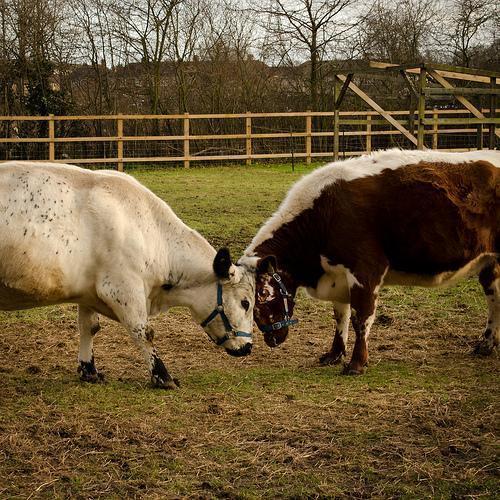How many cows are in the picture?
Give a very brief answer. 2. 